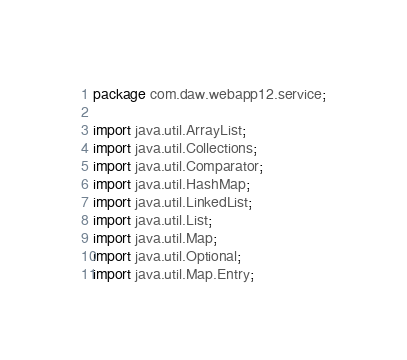<code> <loc_0><loc_0><loc_500><loc_500><_Java_>package com.daw.webapp12.service;

import java.util.ArrayList;
import java.util.Collections;
import java.util.Comparator;
import java.util.HashMap;
import java.util.LinkedList;
import java.util.List;
import java.util.Map;
import java.util.Optional;
import java.util.Map.Entry;
</code> 